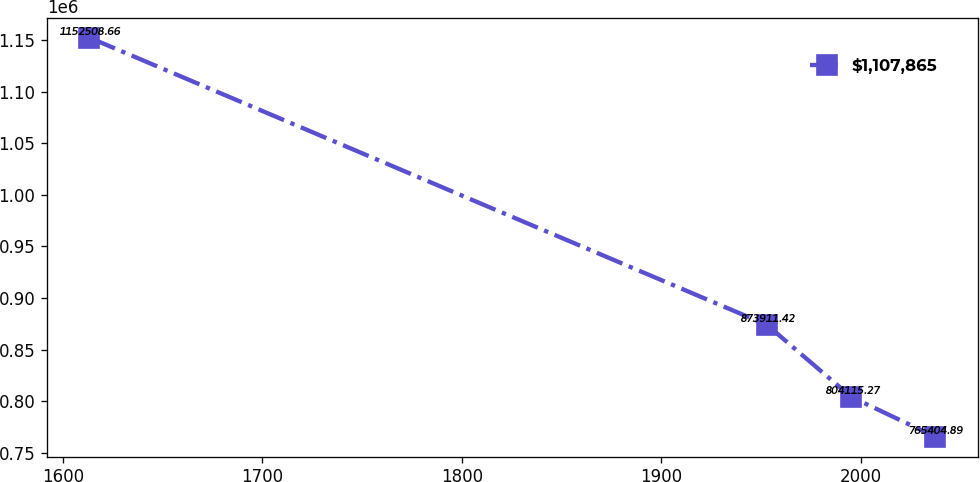Convert chart to OTSL. <chart><loc_0><loc_0><loc_500><loc_500><line_chart><ecel><fcel>$1,107,865<nl><fcel>1613.25<fcel>1.15251e+06<nl><fcel>1953.01<fcel>873911<nl><fcel>1995.2<fcel>804115<nl><fcel>2037.39<fcel>765405<nl></chart> 